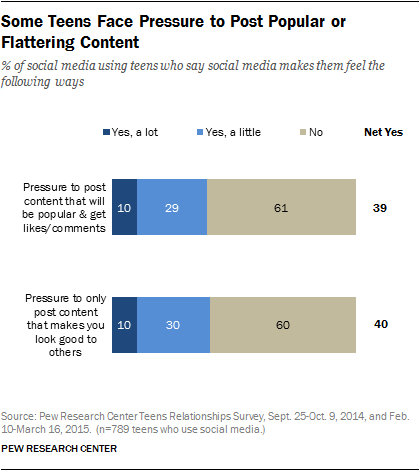Identify some key points in this picture. The average value of the number of observations in these two bars is approximately 60.5. 